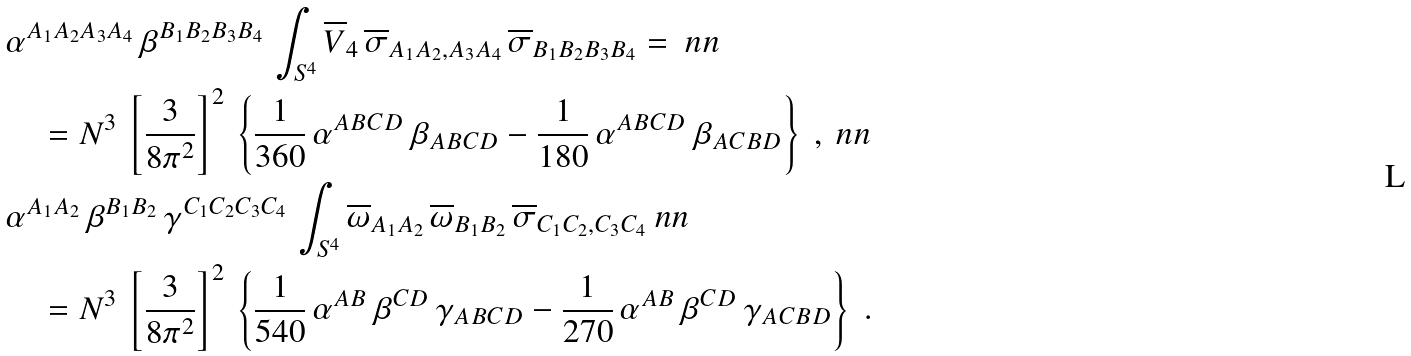<formula> <loc_0><loc_0><loc_500><loc_500>& \alpha ^ { A _ { 1 } A _ { 2 } A _ { 3 } A _ { 4 } } \, \beta ^ { B _ { 1 } B _ { 2 } B _ { 3 } B _ { 4 } } \, \int _ { S ^ { 4 } } \overline { V } _ { 4 } \, \overline { \sigma } _ { A _ { 1 } A _ { 2 } , A _ { 3 } A _ { 4 } } \, \overline { \sigma } _ { B _ { 1 } B _ { 2 } B _ { 3 } B _ { 4 } } = \ n n \\ & \quad = N ^ { 3 } \, \left [ \frac { 3 } { 8 \pi ^ { 2 } } \right ] ^ { 2 } \, \left \{ \frac { 1 } { 3 6 0 } \, \alpha ^ { A B C D } \, \beta _ { A B C D } - \frac { 1 } { 1 8 0 } \, \alpha ^ { A B C D } \, \beta _ { A C B D } \right \} \ , \ n n \\ & \alpha ^ { A _ { 1 } A _ { 2 } } \, \beta ^ { B _ { 1 } B _ { 2 } } \, \gamma ^ { C _ { 1 } C _ { 2 } C _ { 3 } C _ { 4 } } \, \int _ { S ^ { 4 } } \overline { \omega } _ { A _ { 1 } A _ { 2 } } \, \overline { \omega } _ { B _ { 1 } B _ { 2 } } \, \overline { \sigma } _ { C _ { 1 } C _ { 2 } , C _ { 3 } C _ { 4 } } \ n n \\ & \quad = N ^ { 3 } \, \left [ \frac { 3 } { 8 \pi ^ { 2 } } \right ] ^ { 2 } \, \left \{ \frac { 1 } { 5 4 0 } \, \alpha ^ { A B } \, \beta ^ { C D } \, \gamma _ { A B C D } - \frac { 1 } { 2 7 0 } \, \alpha ^ { A B } \, \beta ^ { C D } \, \gamma _ { A C B D } \right \} \ .</formula> 